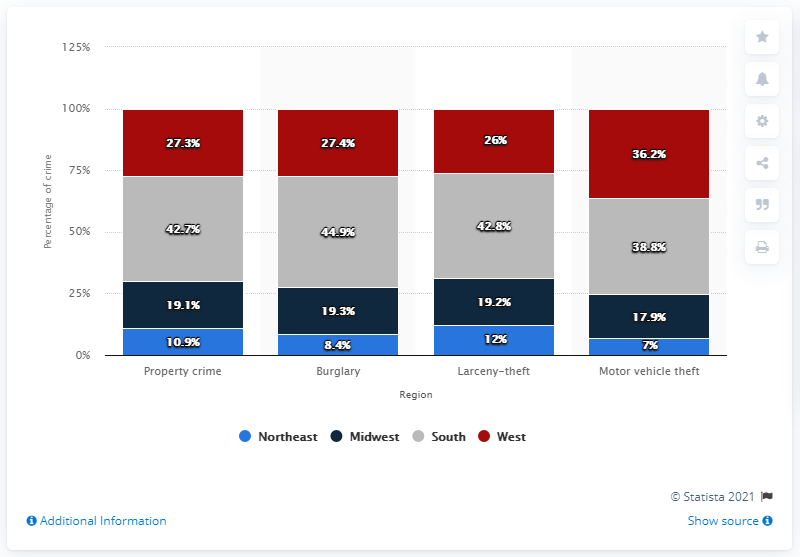Highlight a few significant elements in this photo. The red bar in the chart represents West. In 2019, approximately 42.7% of property crimes were committed in the South region of the United States. On average, the color navy blue is associated with a value of 18.88 in a set of bars. 